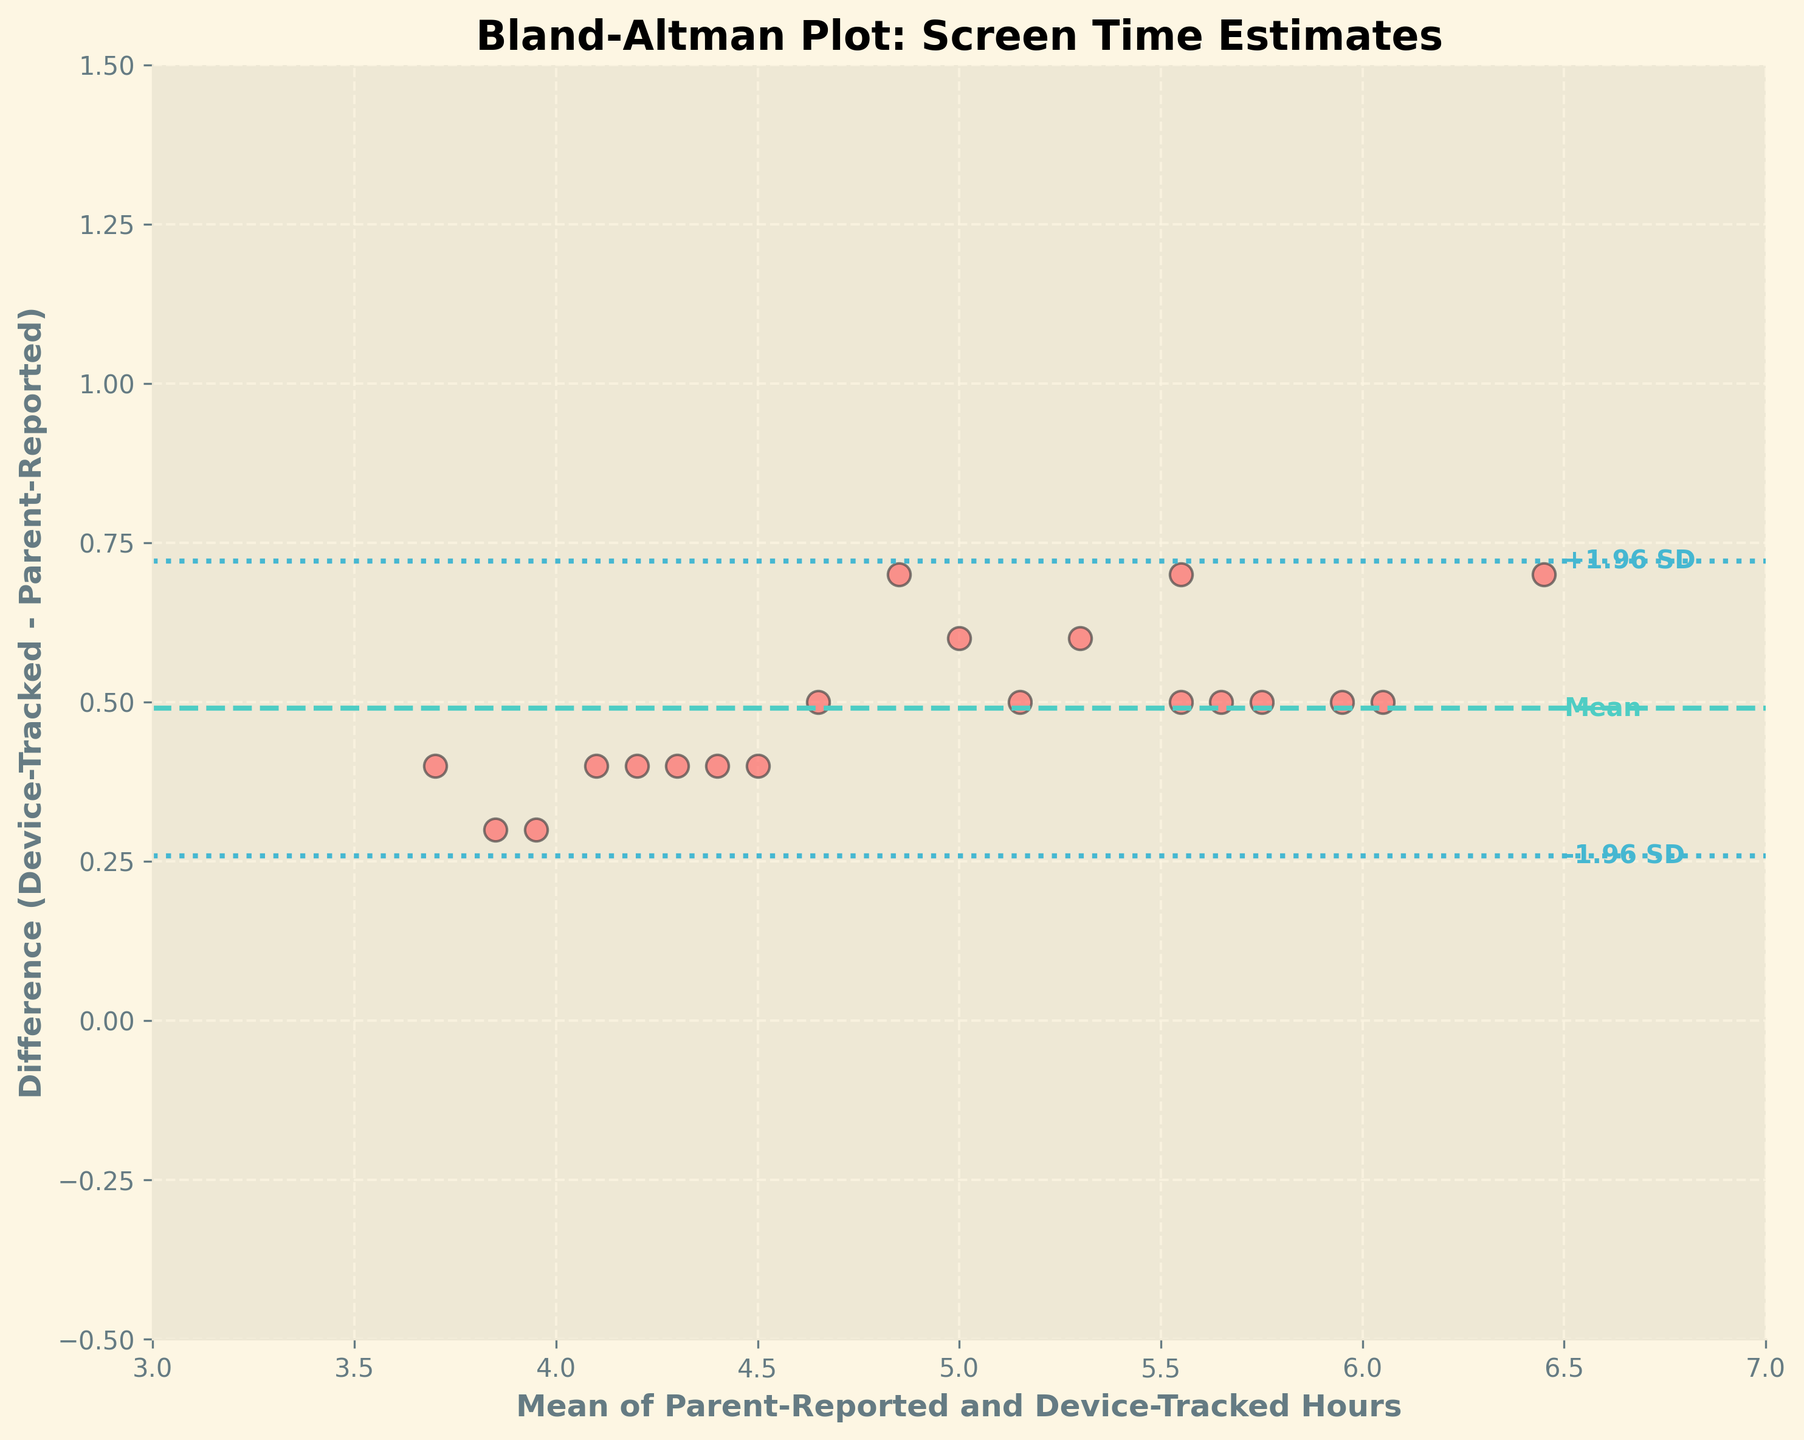What is the title of the figure? The title is usually found above the plot and provides a brief description of what the plot represents.
Answer: Bland-Altman Plot: Screen Time Estimates How many data points are displayed in the plot? Count the number of scatter points in the plot to determine the total number of data points.
Answer: 20 What is the color of the line representing the mean difference? The mean difference line is usually highlighted in a distinct color; in this case, look for the line different from the data points' color.
Answer: Teal What do the dotted lines represent in the plot? The dotted lines in a Bland-Altman plot typically represent the limits of agreement, which are ±1.96 times the standard deviation from the mean difference.
Answer: Limits of agreement Is there generally a large or small mean difference between parent-reported and device-tracked screen time? Look at the position of the mean difference line relative to zero. If it's close to zero, the difference is small; if far, the difference is large.
Answer: Small What is the range of the x-axis in the plot? Examine the x-axis to find the minimum and maximum values marked on it.
Answer: 3 to 7 How are the limits of agreement expressed relative to the average of the differences? Check where the dotted lines are positioned in relation to the mean difference line and the average differences.
Answer: ±1.96 standard deviations What is the mean difference between parent-reported and device-tracked hours of screen time? Observe the y-value where the mean difference line is drawn on the plot.
Answer: Approx. 0.5 hours How do the differences vary with the mean screen time hours? Look for any patterns or trends in the scatter points as the mean increases on the x-axis.
Answer: No obvious trend Which child reported screen time that's closest to the device-tracked time? Find the scatter point that lies closest to the zero line on the y-axis, representing minimal difference.
Answer: Noah 